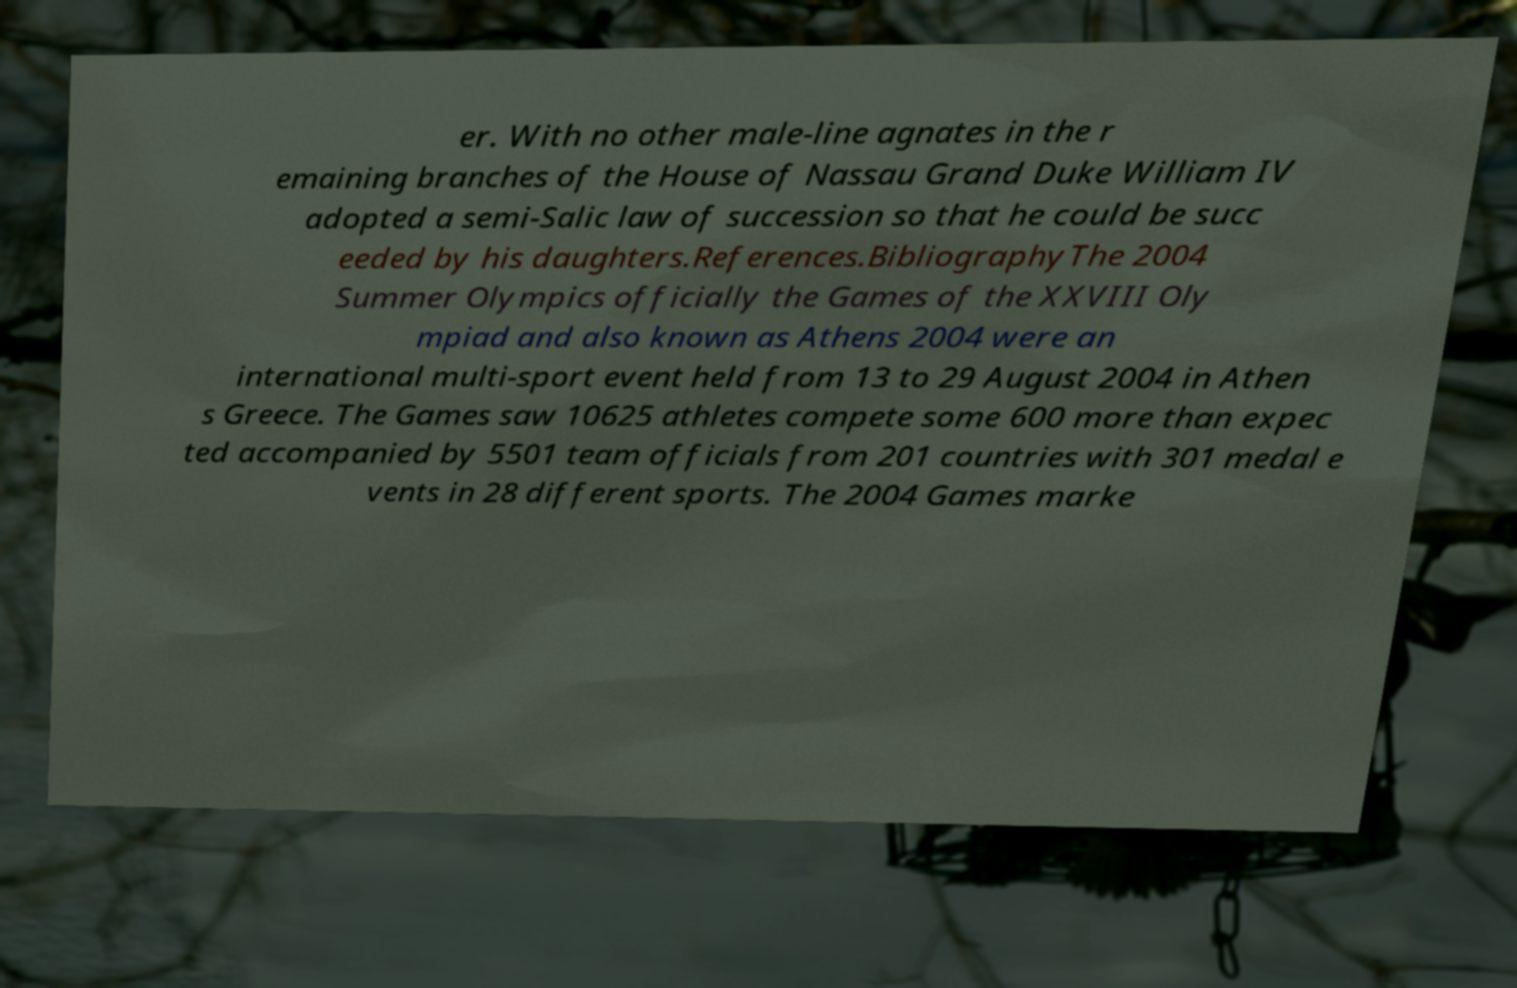For documentation purposes, I need the text within this image transcribed. Could you provide that? er. With no other male-line agnates in the r emaining branches of the House of Nassau Grand Duke William IV adopted a semi-Salic law of succession so that he could be succ eeded by his daughters.References.BibliographyThe 2004 Summer Olympics officially the Games of the XXVIII Oly mpiad and also known as Athens 2004 were an international multi-sport event held from 13 to 29 August 2004 in Athen s Greece. The Games saw 10625 athletes compete some 600 more than expec ted accompanied by 5501 team officials from 201 countries with 301 medal e vents in 28 different sports. The 2004 Games marke 